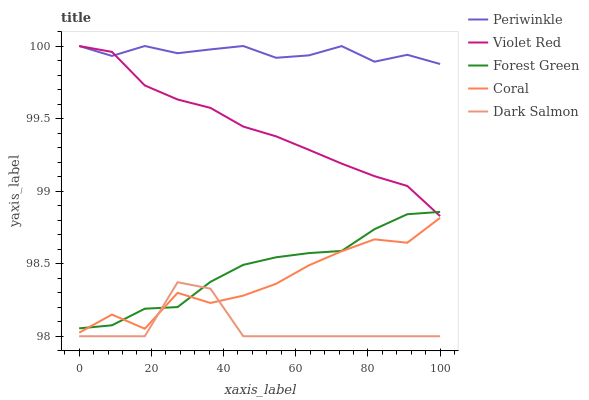Does Dark Salmon have the minimum area under the curve?
Answer yes or no. Yes. Does Periwinkle have the maximum area under the curve?
Answer yes or no. Yes. Does Violet Red have the minimum area under the curve?
Answer yes or no. No. Does Violet Red have the maximum area under the curve?
Answer yes or no. No. Is Violet Red the smoothest?
Answer yes or no. Yes. Is Coral the roughest?
Answer yes or no. Yes. Is Periwinkle the smoothest?
Answer yes or no. No. Is Periwinkle the roughest?
Answer yes or no. No. Does Dark Salmon have the lowest value?
Answer yes or no. Yes. Does Violet Red have the lowest value?
Answer yes or no. No. Does Periwinkle have the highest value?
Answer yes or no. Yes. Does Forest Green have the highest value?
Answer yes or no. No. Is Dark Salmon less than Violet Red?
Answer yes or no. Yes. Is Periwinkle greater than Dark Salmon?
Answer yes or no. Yes. Does Forest Green intersect Dark Salmon?
Answer yes or no. Yes. Is Forest Green less than Dark Salmon?
Answer yes or no. No. Is Forest Green greater than Dark Salmon?
Answer yes or no. No. Does Dark Salmon intersect Violet Red?
Answer yes or no. No. 